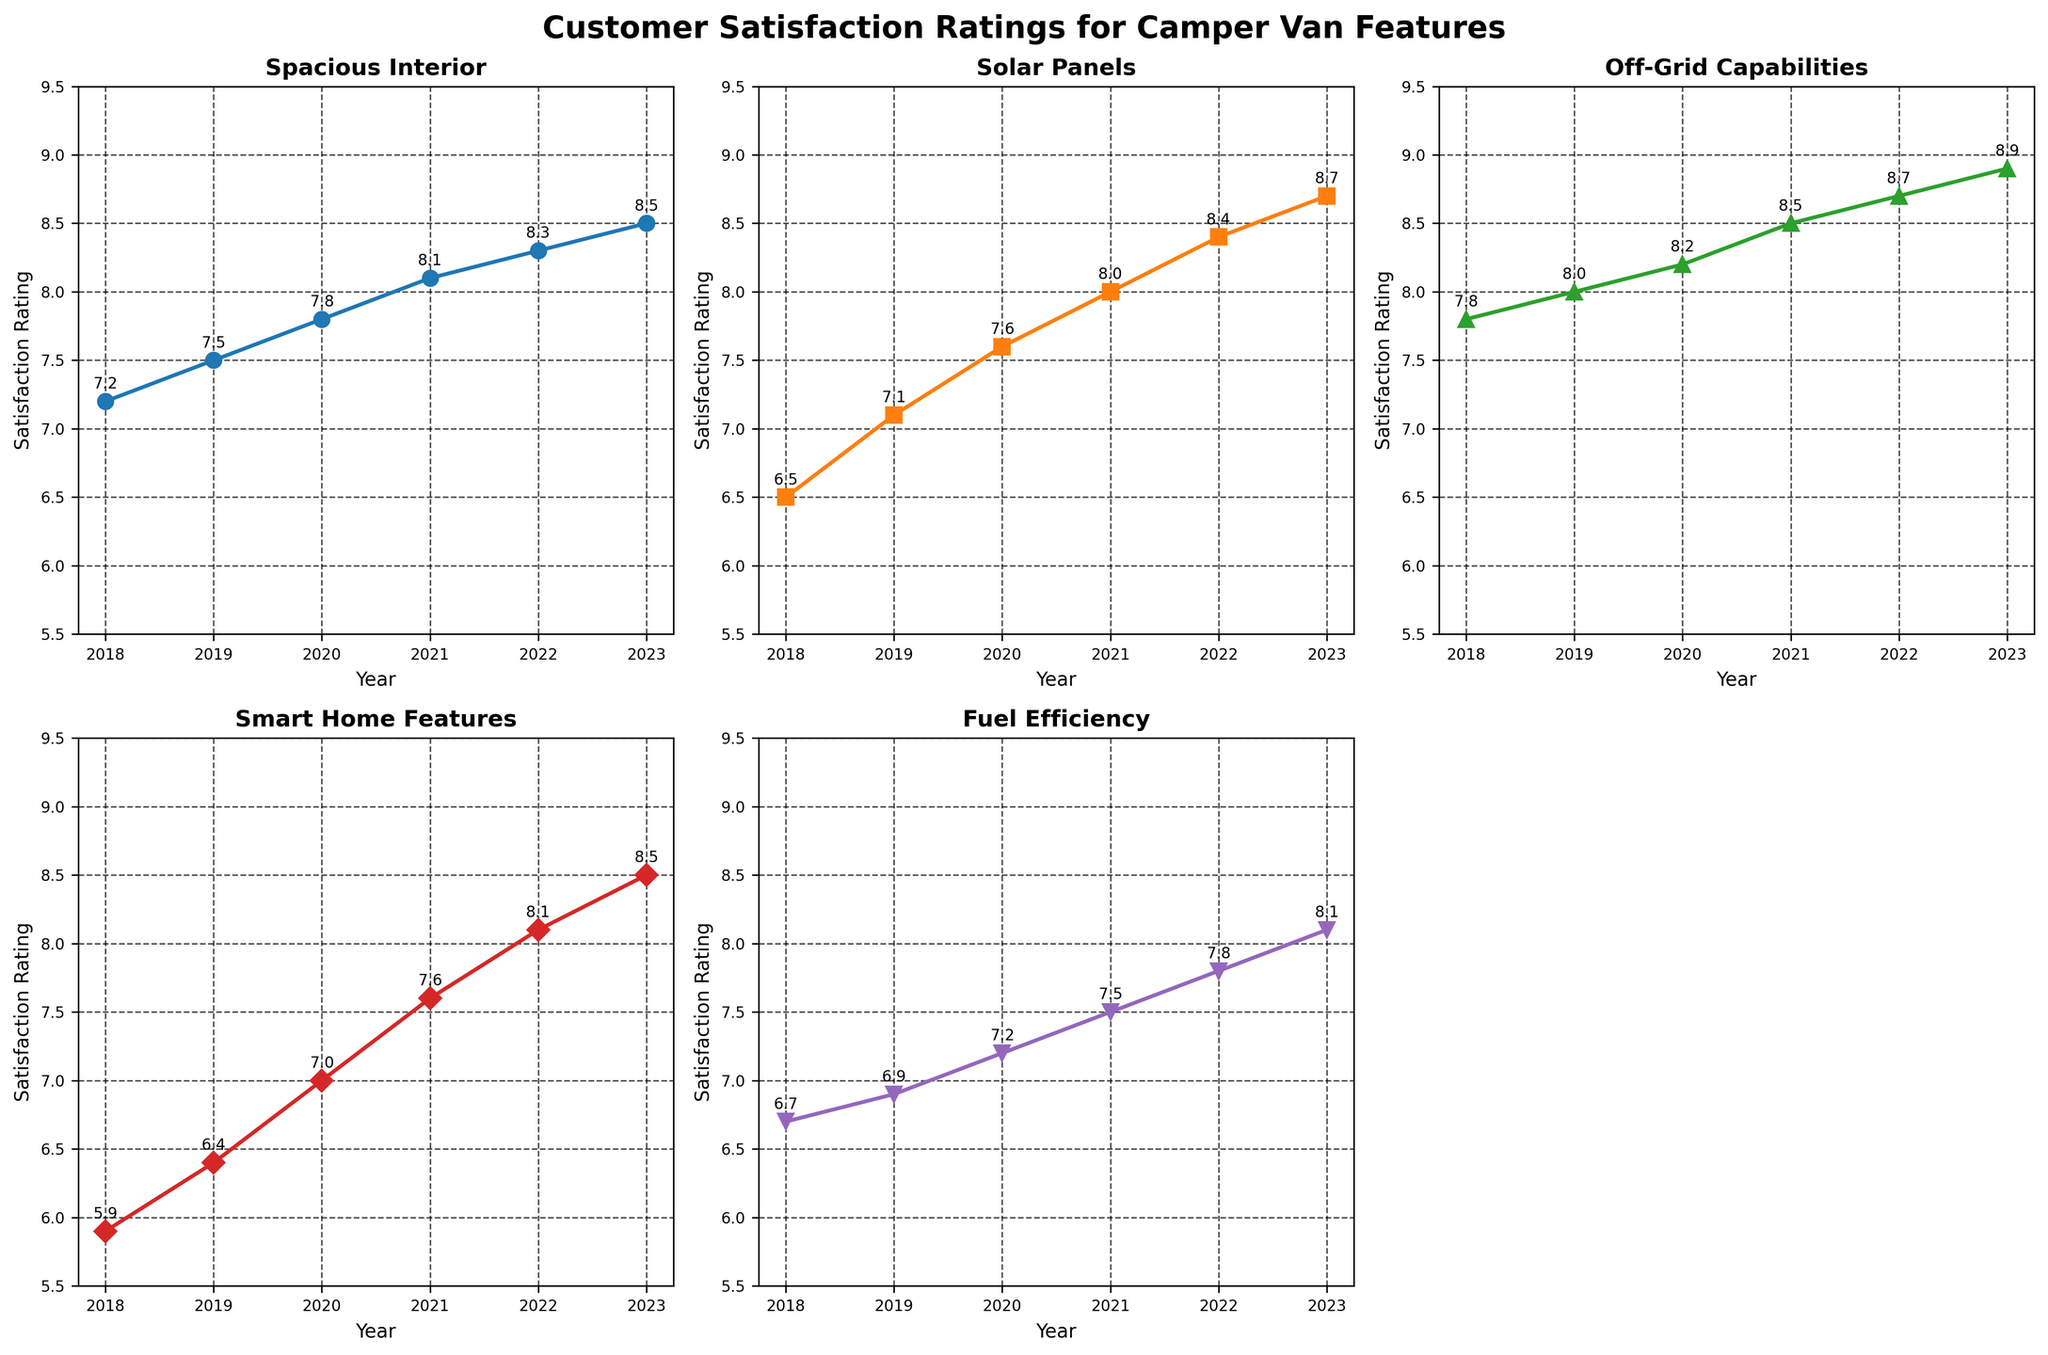What is the title of the figure? The title is displayed at the top of the figure, reading "Customer Satisfaction Ratings for Camper Van Features". This can be identified by its larger font size and bold formatting compared to other texts.
Answer: Customer Satisfaction Ratings for Camper Van Features How did the satisfaction rating for Fuel Efficiency change from 2018 to 2023? To find the change, locate the Fuel Efficiency line on the plot. Note the satisfaction rating for the years 2018 and 2023, which are 6.7 and 8.1 respectively. Subtract the 2018 value from the 2023 value (8.1 - 6.7).
Answer: +1.4 Which feature had the highest satisfaction rating in 2023? Look at the 2023 data points for all features. The highest value for 2023 is 8.9, which corresponds to Off-Grid Capabilities.
Answer: Off-Grid Capabilities Which year saw the biggest improvement in the satisfaction rating for Smart Home Features? Analyze the difference between consecutive years' ratings for Smart Home Features. The differences are: 
2019-2018: 6.4-5.9 = +0.5 
2020-2019: 7.0-6.4 = +0.6 
2021-2020: 7.6-7.0 = +0.6 
2022-2021: 8.1-7.6 = +0.5 
2023-2022: 8.5-8.1 = +0.4 
The biggest improvement happens between 2019 and 2020 with a 0.6 increase.
Answer: 2020 Compare the satisfaction trends of Solar Panels and Spacious Interior from 2018 to 2023. Which one grew more? Calculate the increase for both features from 2018 to 2023. 
Solar Panels: 8.7 - 6.5 = +2.2
Spacious Interior: 8.5 - 7.2 = +1.3
Solar Panels had a larger growth in satisfaction from 2018 to 2023.
Answer: Solar Panels In which year did all features observe a satisfaction rating above 7 for the first time? Check each feature's ratings year by year until all are above 7. 
In 2020: 
Spacious Interior = 7.8 
Solar Panels = 7.6 
Off-Grid Capabilities = 8.2 
Smart Home Features = 7.0 
Fuel Efficiency = 7.2
2020 is the first year where all ratings exceed 7.
Answer: 2020 Which feature showed a consistently increasing trend every year? Review the trend lines for each feature. Identify the ones whose satisfaction rating increases every year from 2018 to 2023. Only Off-Grid Capabilities (7.8, 8.0, 8.2, 8.5, 8.7, 8.9) shows a consistent increase.
Answer: Off-Grid Capabilities What is the average satisfaction rating for Solar Panels over the years? Add the satisfaction ratings of Solar Panels for each year and divide by the number of years. (6.5 + 7.1 + 7.6 + 8.0 + 8.4 + 8.7) / 6 = 46.3 / 6 ≈ 7.72
Answer: 7.72 Has any feature ever had a satisfaction rating below 6? Check all feature ratings from 2018 to 2023. The minimum value for each year and each feature are above 6. Thus, no feature has a rating below 6 in any year.
Answer: No 